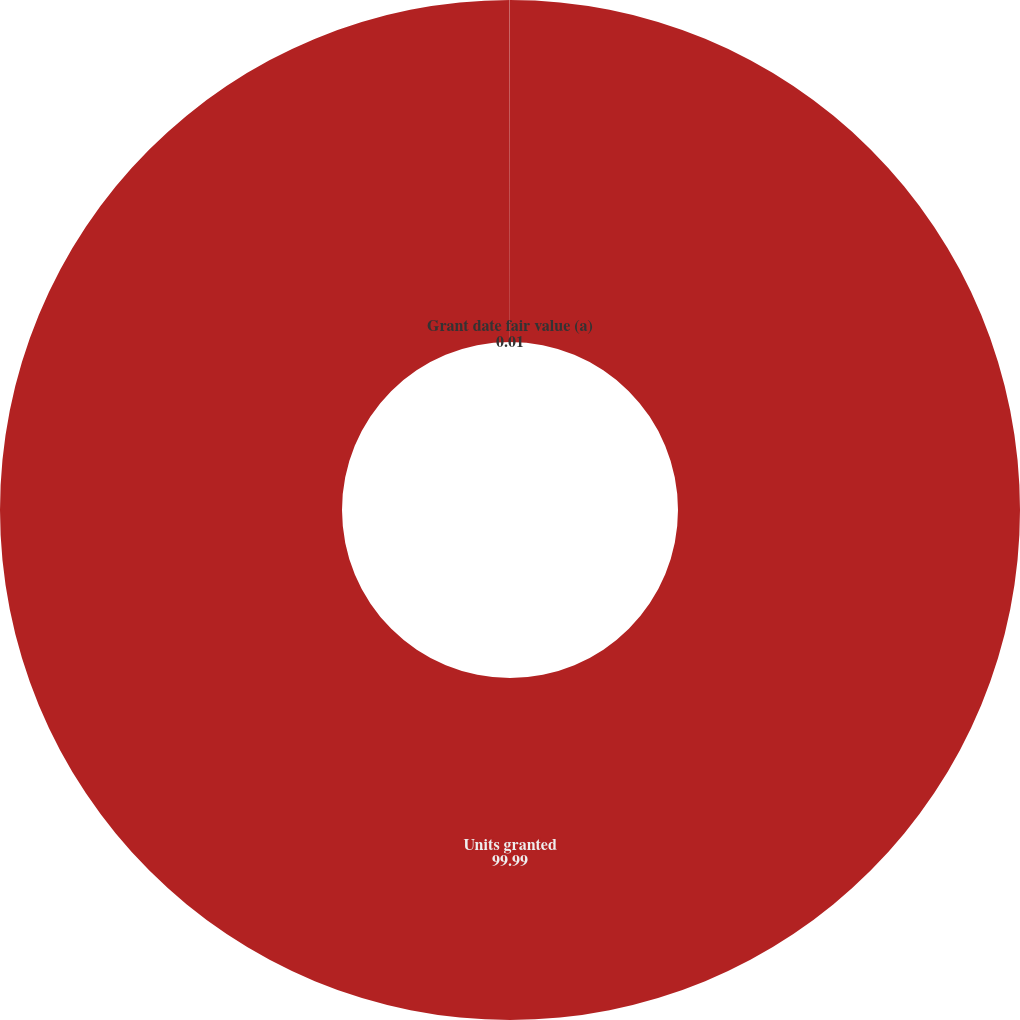<chart> <loc_0><loc_0><loc_500><loc_500><pie_chart><fcel>Units granted<fcel>Grant date fair value (a)<nl><fcel>99.99%<fcel>0.01%<nl></chart> 